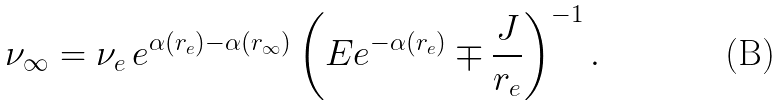Convert formula to latex. <formula><loc_0><loc_0><loc_500><loc_500>\nu _ { \infty } = \nu _ { e } \, e ^ { \alpha ( r _ { e } ) - \alpha ( r _ { \infty } ) } \left ( E e ^ { - \alpha ( r _ { e } ) } \mp \frac { J } { r _ { e } } \right ) ^ { - 1 } .</formula> 